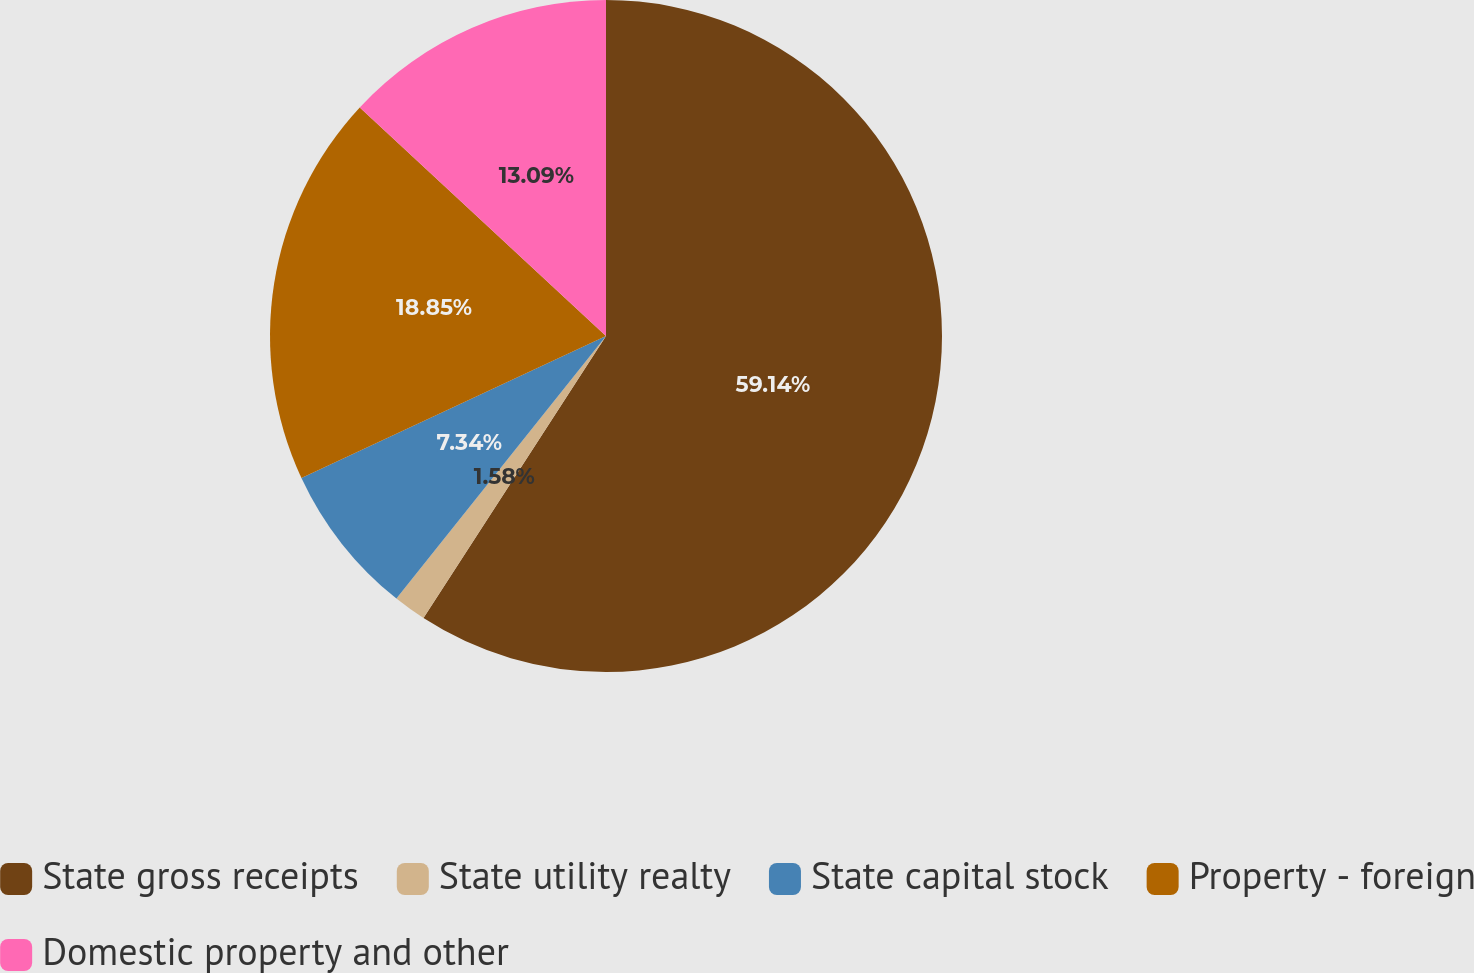Convert chart to OTSL. <chart><loc_0><loc_0><loc_500><loc_500><pie_chart><fcel>State gross receipts<fcel>State utility realty<fcel>State capital stock<fcel>Property - foreign<fcel>Domestic property and other<nl><fcel>59.14%<fcel>1.58%<fcel>7.34%<fcel>18.85%<fcel>13.09%<nl></chart> 